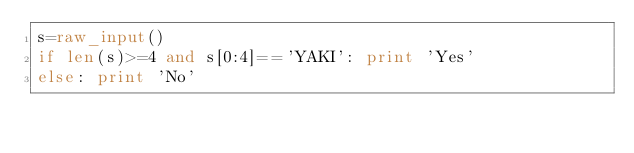<code> <loc_0><loc_0><loc_500><loc_500><_Python_>s=raw_input()
if len(s)>=4 and s[0:4]=='YAKI': print 'Yes'
else: print 'No'</code> 